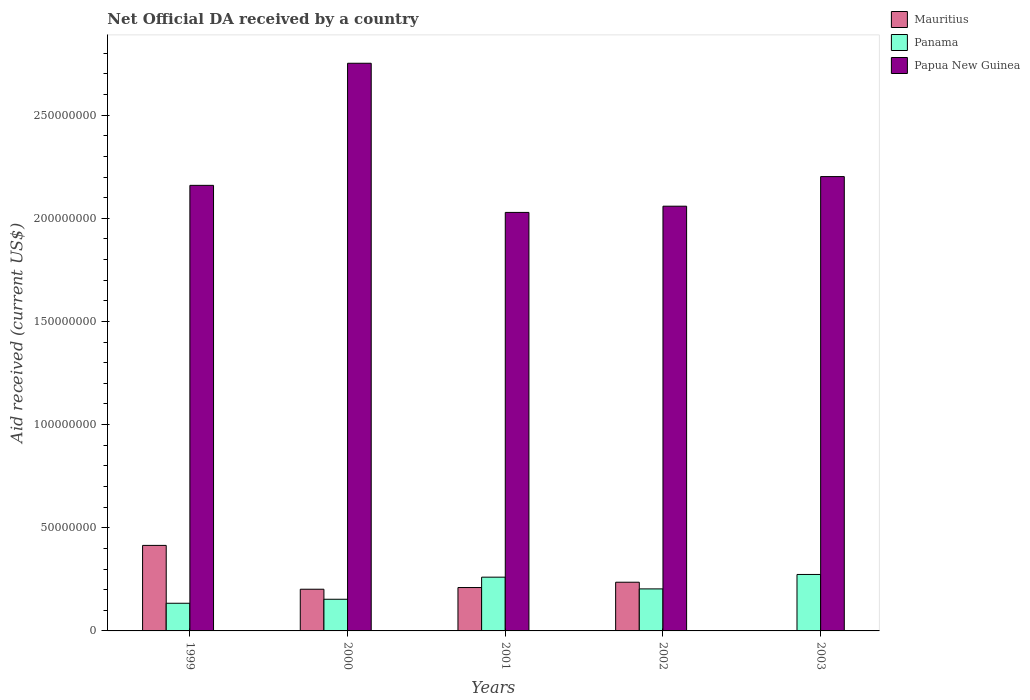How many different coloured bars are there?
Give a very brief answer. 3. How many bars are there on the 2nd tick from the right?
Offer a terse response. 3. What is the label of the 4th group of bars from the left?
Offer a very short reply. 2002. What is the net official development assistance aid received in Mauritius in 1999?
Your answer should be compact. 4.14e+07. Across all years, what is the maximum net official development assistance aid received in Mauritius?
Your answer should be compact. 4.14e+07. Across all years, what is the minimum net official development assistance aid received in Panama?
Provide a short and direct response. 1.34e+07. What is the total net official development assistance aid received in Papua New Guinea in the graph?
Make the answer very short. 1.12e+09. What is the difference between the net official development assistance aid received in Papua New Guinea in 1999 and that in 2001?
Your answer should be compact. 1.31e+07. What is the difference between the net official development assistance aid received in Mauritius in 2000 and the net official development assistance aid received in Papua New Guinea in 2002?
Keep it short and to the point. -1.86e+08. What is the average net official development assistance aid received in Papua New Guinea per year?
Your response must be concise. 2.24e+08. In the year 1999, what is the difference between the net official development assistance aid received in Papua New Guinea and net official development assistance aid received in Panama?
Ensure brevity in your answer.  2.03e+08. What is the ratio of the net official development assistance aid received in Mauritius in 1999 to that in 2002?
Give a very brief answer. 1.76. What is the difference between the highest and the second highest net official development assistance aid received in Papua New Guinea?
Offer a very short reply. 5.49e+07. What is the difference between the highest and the lowest net official development assistance aid received in Mauritius?
Provide a succinct answer. 4.14e+07. Is the sum of the net official development assistance aid received in Mauritius in 2001 and 2002 greater than the maximum net official development assistance aid received in Papua New Guinea across all years?
Offer a terse response. No. Is it the case that in every year, the sum of the net official development assistance aid received in Panama and net official development assistance aid received in Mauritius is greater than the net official development assistance aid received in Papua New Guinea?
Provide a succinct answer. No. How many bars are there?
Provide a short and direct response. 14. Are all the bars in the graph horizontal?
Your answer should be compact. No. How many years are there in the graph?
Provide a succinct answer. 5. What is the difference between two consecutive major ticks on the Y-axis?
Keep it short and to the point. 5.00e+07. Where does the legend appear in the graph?
Your answer should be very brief. Top right. How many legend labels are there?
Provide a succinct answer. 3. How are the legend labels stacked?
Keep it short and to the point. Vertical. What is the title of the graph?
Make the answer very short. Net Official DA received by a country. Does "India" appear as one of the legend labels in the graph?
Your answer should be very brief. No. What is the label or title of the X-axis?
Offer a very short reply. Years. What is the label or title of the Y-axis?
Your answer should be compact. Aid received (current US$). What is the Aid received (current US$) in Mauritius in 1999?
Offer a very short reply. 4.14e+07. What is the Aid received (current US$) of Panama in 1999?
Offer a terse response. 1.34e+07. What is the Aid received (current US$) in Papua New Guinea in 1999?
Ensure brevity in your answer.  2.16e+08. What is the Aid received (current US$) in Mauritius in 2000?
Make the answer very short. 2.02e+07. What is the Aid received (current US$) of Panama in 2000?
Provide a succinct answer. 1.54e+07. What is the Aid received (current US$) in Papua New Guinea in 2000?
Give a very brief answer. 2.75e+08. What is the Aid received (current US$) of Mauritius in 2001?
Offer a very short reply. 2.10e+07. What is the Aid received (current US$) in Panama in 2001?
Give a very brief answer. 2.61e+07. What is the Aid received (current US$) in Papua New Guinea in 2001?
Provide a short and direct response. 2.03e+08. What is the Aid received (current US$) of Mauritius in 2002?
Make the answer very short. 2.36e+07. What is the Aid received (current US$) in Panama in 2002?
Your response must be concise. 2.04e+07. What is the Aid received (current US$) in Papua New Guinea in 2002?
Offer a terse response. 2.06e+08. What is the Aid received (current US$) of Mauritius in 2003?
Keep it short and to the point. 0. What is the Aid received (current US$) of Panama in 2003?
Give a very brief answer. 2.74e+07. What is the Aid received (current US$) in Papua New Guinea in 2003?
Provide a succinct answer. 2.20e+08. Across all years, what is the maximum Aid received (current US$) of Mauritius?
Provide a short and direct response. 4.14e+07. Across all years, what is the maximum Aid received (current US$) in Panama?
Make the answer very short. 2.74e+07. Across all years, what is the maximum Aid received (current US$) in Papua New Guinea?
Your response must be concise. 2.75e+08. Across all years, what is the minimum Aid received (current US$) in Mauritius?
Keep it short and to the point. 0. Across all years, what is the minimum Aid received (current US$) of Panama?
Your answer should be compact. 1.34e+07. Across all years, what is the minimum Aid received (current US$) in Papua New Guinea?
Ensure brevity in your answer.  2.03e+08. What is the total Aid received (current US$) in Mauritius in the graph?
Provide a succinct answer. 1.06e+08. What is the total Aid received (current US$) in Panama in the graph?
Make the answer very short. 1.03e+08. What is the total Aid received (current US$) in Papua New Guinea in the graph?
Keep it short and to the point. 1.12e+09. What is the difference between the Aid received (current US$) in Mauritius in 1999 and that in 2000?
Ensure brevity in your answer.  2.12e+07. What is the difference between the Aid received (current US$) of Panama in 1999 and that in 2000?
Give a very brief answer. -1.94e+06. What is the difference between the Aid received (current US$) of Papua New Guinea in 1999 and that in 2000?
Keep it short and to the point. -5.92e+07. What is the difference between the Aid received (current US$) of Mauritius in 1999 and that in 2001?
Provide a short and direct response. 2.04e+07. What is the difference between the Aid received (current US$) of Panama in 1999 and that in 2001?
Your response must be concise. -1.26e+07. What is the difference between the Aid received (current US$) of Papua New Guinea in 1999 and that in 2001?
Keep it short and to the point. 1.31e+07. What is the difference between the Aid received (current US$) in Mauritius in 1999 and that in 2002?
Your response must be concise. 1.78e+07. What is the difference between the Aid received (current US$) of Panama in 1999 and that in 2002?
Give a very brief answer. -6.96e+06. What is the difference between the Aid received (current US$) in Papua New Guinea in 1999 and that in 2002?
Make the answer very short. 1.01e+07. What is the difference between the Aid received (current US$) in Panama in 1999 and that in 2003?
Your answer should be very brief. -1.40e+07. What is the difference between the Aid received (current US$) in Papua New Guinea in 1999 and that in 2003?
Provide a short and direct response. -4.25e+06. What is the difference between the Aid received (current US$) of Mauritius in 2000 and that in 2001?
Your answer should be compact. -8.20e+05. What is the difference between the Aid received (current US$) of Panama in 2000 and that in 2001?
Your response must be concise. -1.07e+07. What is the difference between the Aid received (current US$) of Papua New Guinea in 2000 and that in 2001?
Your answer should be very brief. 7.23e+07. What is the difference between the Aid received (current US$) of Mauritius in 2000 and that in 2002?
Offer a terse response. -3.39e+06. What is the difference between the Aid received (current US$) of Panama in 2000 and that in 2002?
Provide a succinct answer. -5.02e+06. What is the difference between the Aid received (current US$) of Papua New Guinea in 2000 and that in 2002?
Your answer should be compact. 6.93e+07. What is the difference between the Aid received (current US$) in Panama in 2000 and that in 2003?
Keep it short and to the point. -1.20e+07. What is the difference between the Aid received (current US$) in Papua New Guinea in 2000 and that in 2003?
Provide a short and direct response. 5.49e+07. What is the difference between the Aid received (current US$) in Mauritius in 2001 and that in 2002?
Your response must be concise. -2.57e+06. What is the difference between the Aid received (current US$) in Panama in 2001 and that in 2002?
Offer a very short reply. 5.69e+06. What is the difference between the Aid received (current US$) of Papua New Guinea in 2001 and that in 2002?
Your answer should be very brief. -3.02e+06. What is the difference between the Aid received (current US$) in Panama in 2001 and that in 2003?
Make the answer very short. -1.31e+06. What is the difference between the Aid received (current US$) in Papua New Guinea in 2001 and that in 2003?
Your response must be concise. -1.74e+07. What is the difference between the Aid received (current US$) of Panama in 2002 and that in 2003?
Ensure brevity in your answer.  -7.00e+06. What is the difference between the Aid received (current US$) in Papua New Guinea in 2002 and that in 2003?
Make the answer very short. -1.44e+07. What is the difference between the Aid received (current US$) in Mauritius in 1999 and the Aid received (current US$) in Panama in 2000?
Keep it short and to the point. 2.61e+07. What is the difference between the Aid received (current US$) in Mauritius in 1999 and the Aid received (current US$) in Papua New Guinea in 2000?
Your answer should be very brief. -2.34e+08. What is the difference between the Aid received (current US$) in Panama in 1999 and the Aid received (current US$) in Papua New Guinea in 2000?
Keep it short and to the point. -2.62e+08. What is the difference between the Aid received (current US$) in Mauritius in 1999 and the Aid received (current US$) in Panama in 2001?
Provide a succinct answer. 1.54e+07. What is the difference between the Aid received (current US$) of Mauritius in 1999 and the Aid received (current US$) of Papua New Guinea in 2001?
Provide a short and direct response. -1.61e+08. What is the difference between the Aid received (current US$) in Panama in 1999 and the Aid received (current US$) in Papua New Guinea in 2001?
Ensure brevity in your answer.  -1.89e+08. What is the difference between the Aid received (current US$) of Mauritius in 1999 and the Aid received (current US$) of Panama in 2002?
Your answer should be very brief. 2.11e+07. What is the difference between the Aid received (current US$) in Mauritius in 1999 and the Aid received (current US$) in Papua New Guinea in 2002?
Make the answer very short. -1.64e+08. What is the difference between the Aid received (current US$) in Panama in 1999 and the Aid received (current US$) in Papua New Guinea in 2002?
Offer a very short reply. -1.92e+08. What is the difference between the Aid received (current US$) in Mauritius in 1999 and the Aid received (current US$) in Panama in 2003?
Offer a terse response. 1.41e+07. What is the difference between the Aid received (current US$) of Mauritius in 1999 and the Aid received (current US$) of Papua New Guinea in 2003?
Ensure brevity in your answer.  -1.79e+08. What is the difference between the Aid received (current US$) of Panama in 1999 and the Aid received (current US$) of Papua New Guinea in 2003?
Ensure brevity in your answer.  -2.07e+08. What is the difference between the Aid received (current US$) of Mauritius in 2000 and the Aid received (current US$) of Panama in 2001?
Ensure brevity in your answer.  -5.85e+06. What is the difference between the Aid received (current US$) of Mauritius in 2000 and the Aid received (current US$) of Papua New Guinea in 2001?
Your answer should be very brief. -1.83e+08. What is the difference between the Aid received (current US$) of Panama in 2000 and the Aid received (current US$) of Papua New Guinea in 2001?
Provide a succinct answer. -1.88e+08. What is the difference between the Aid received (current US$) in Mauritius in 2000 and the Aid received (current US$) in Papua New Guinea in 2002?
Your answer should be compact. -1.86e+08. What is the difference between the Aid received (current US$) in Panama in 2000 and the Aid received (current US$) in Papua New Guinea in 2002?
Keep it short and to the point. -1.91e+08. What is the difference between the Aid received (current US$) of Mauritius in 2000 and the Aid received (current US$) of Panama in 2003?
Offer a very short reply. -7.16e+06. What is the difference between the Aid received (current US$) in Mauritius in 2000 and the Aid received (current US$) in Papua New Guinea in 2003?
Your response must be concise. -2.00e+08. What is the difference between the Aid received (current US$) of Panama in 2000 and the Aid received (current US$) of Papua New Guinea in 2003?
Offer a terse response. -2.05e+08. What is the difference between the Aid received (current US$) in Mauritius in 2001 and the Aid received (current US$) in Papua New Guinea in 2002?
Your answer should be compact. -1.85e+08. What is the difference between the Aid received (current US$) of Panama in 2001 and the Aid received (current US$) of Papua New Guinea in 2002?
Keep it short and to the point. -1.80e+08. What is the difference between the Aid received (current US$) in Mauritius in 2001 and the Aid received (current US$) in Panama in 2003?
Your answer should be compact. -6.34e+06. What is the difference between the Aid received (current US$) of Mauritius in 2001 and the Aid received (current US$) of Papua New Guinea in 2003?
Make the answer very short. -1.99e+08. What is the difference between the Aid received (current US$) of Panama in 2001 and the Aid received (current US$) of Papua New Guinea in 2003?
Your answer should be compact. -1.94e+08. What is the difference between the Aid received (current US$) of Mauritius in 2002 and the Aid received (current US$) of Panama in 2003?
Your answer should be compact. -3.77e+06. What is the difference between the Aid received (current US$) in Mauritius in 2002 and the Aid received (current US$) in Papua New Guinea in 2003?
Your response must be concise. -1.97e+08. What is the difference between the Aid received (current US$) of Panama in 2002 and the Aid received (current US$) of Papua New Guinea in 2003?
Offer a terse response. -2.00e+08. What is the average Aid received (current US$) in Mauritius per year?
Provide a short and direct response. 2.13e+07. What is the average Aid received (current US$) of Panama per year?
Offer a very short reply. 2.05e+07. What is the average Aid received (current US$) of Papua New Guinea per year?
Your response must be concise. 2.24e+08. In the year 1999, what is the difference between the Aid received (current US$) in Mauritius and Aid received (current US$) in Panama?
Provide a short and direct response. 2.80e+07. In the year 1999, what is the difference between the Aid received (current US$) in Mauritius and Aid received (current US$) in Papua New Guinea?
Your answer should be very brief. -1.75e+08. In the year 1999, what is the difference between the Aid received (current US$) in Panama and Aid received (current US$) in Papua New Guinea?
Give a very brief answer. -2.03e+08. In the year 2000, what is the difference between the Aid received (current US$) in Mauritius and Aid received (current US$) in Panama?
Your response must be concise. 4.86e+06. In the year 2000, what is the difference between the Aid received (current US$) of Mauritius and Aid received (current US$) of Papua New Guinea?
Provide a succinct answer. -2.55e+08. In the year 2000, what is the difference between the Aid received (current US$) of Panama and Aid received (current US$) of Papua New Guinea?
Provide a succinct answer. -2.60e+08. In the year 2001, what is the difference between the Aid received (current US$) of Mauritius and Aid received (current US$) of Panama?
Your response must be concise. -5.03e+06. In the year 2001, what is the difference between the Aid received (current US$) in Mauritius and Aid received (current US$) in Papua New Guinea?
Your response must be concise. -1.82e+08. In the year 2001, what is the difference between the Aid received (current US$) in Panama and Aid received (current US$) in Papua New Guinea?
Offer a terse response. -1.77e+08. In the year 2002, what is the difference between the Aid received (current US$) in Mauritius and Aid received (current US$) in Panama?
Keep it short and to the point. 3.23e+06. In the year 2002, what is the difference between the Aid received (current US$) of Mauritius and Aid received (current US$) of Papua New Guinea?
Your answer should be compact. -1.82e+08. In the year 2002, what is the difference between the Aid received (current US$) of Panama and Aid received (current US$) of Papua New Guinea?
Offer a very short reply. -1.86e+08. In the year 2003, what is the difference between the Aid received (current US$) of Panama and Aid received (current US$) of Papua New Guinea?
Make the answer very short. -1.93e+08. What is the ratio of the Aid received (current US$) in Mauritius in 1999 to that in 2000?
Make the answer very short. 2.05. What is the ratio of the Aid received (current US$) in Panama in 1999 to that in 2000?
Your response must be concise. 0.87. What is the ratio of the Aid received (current US$) in Papua New Guinea in 1999 to that in 2000?
Provide a succinct answer. 0.78. What is the ratio of the Aid received (current US$) in Mauritius in 1999 to that in 2001?
Offer a terse response. 1.97. What is the ratio of the Aid received (current US$) of Panama in 1999 to that in 2001?
Give a very brief answer. 0.51. What is the ratio of the Aid received (current US$) of Papua New Guinea in 1999 to that in 2001?
Your answer should be very brief. 1.06. What is the ratio of the Aid received (current US$) in Mauritius in 1999 to that in 2002?
Your answer should be very brief. 1.76. What is the ratio of the Aid received (current US$) of Panama in 1999 to that in 2002?
Ensure brevity in your answer.  0.66. What is the ratio of the Aid received (current US$) in Papua New Guinea in 1999 to that in 2002?
Provide a succinct answer. 1.05. What is the ratio of the Aid received (current US$) in Panama in 1999 to that in 2003?
Provide a succinct answer. 0.49. What is the ratio of the Aid received (current US$) of Papua New Guinea in 1999 to that in 2003?
Make the answer very short. 0.98. What is the ratio of the Aid received (current US$) of Mauritius in 2000 to that in 2001?
Make the answer very short. 0.96. What is the ratio of the Aid received (current US$) of Panama in 2000 to that in 2001?
Offer a very short reply. 0.59. What is the ratio of the Aid received (current US$) of Papua New Guinea in 2000 to that in 2001?
Keep it short and to the point. 1.36. What is the ratio of the Aid received (current US$) in Mauritius in 2000 to that in 2002?
Your answer should be very brief. 0.86. What is the ratio of the Aid received (current US$) in Panama in 2000 to that in 2002?
Give a very brief answer. 0.75. What is the ratio of the Aid received (current US$) in Papua New Guinea in 2000 to that in 2002?
Offer a terse response. 1.34. What is the ratio of the Aid received (current US$) of Panama in 2000 to that in 2003?
Provide a short and direct response. 0.56. What is the ratio of the Aid received (current US$) in Papua New Guinea in 2000 to that in 2003?
Your answer should be compact. 1.25. What is the ratio of the Aid received (current US$) of Mauritius in 2001 to that in 2002?
Keep it short and to the point. 0.89. What is the ratio of the Aid received (current US$) of Panama in 2001 to that in 2002?
Provide a succinct answer. 1.28. What is the ratio of the Aid received (current US$) of Panama in 2001 to that in 2003?
Make the answer very short. 0.95. What is the ratio of the Aid received (current US$) in Papua New Guinea in 2001 to that in 2003?
Provide a short and direct response. 0.92. What is the ratio of the Aid received (current US$) in Panama in 2002 to that in 2003?
Provide a short and direct response. 0.74. What is the ratio of the Aid received (current US$) in Papua New Guinea in 2002 to that in 2003?
Keep it short and to the point. 0.93. What is the difference between the highest and the second highest Aid received (current US$) in Mauritius?
Make the answer very short. 1.78e+07. What is the difference between the highest and the second highest Aid received (current US$) of Panama?
Your response must be concise. 1.31e+06. What is the difference between the highest and the second highest Aid received (current US$) of Papua New Guinea?
Provide a succinct answer. 5.49e+07. What is the difference between the highest and the lowest Aid received (current US$) of Mauritius?
Offer a very short reply. 4.14e+07. What is the difference between the highest and the lowest Aid received (current US$) in Panama?
Make the answer very short. 1.40e+07. What is the difference between the highest and the lowest Aid received (current US$) of Papua New Guinea?
Keep it short and to the point. 7.23e+07. 